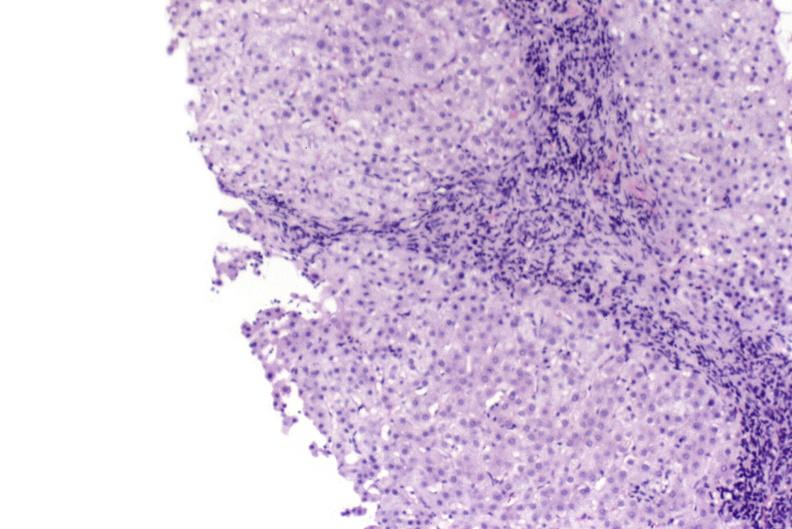does right leaf of diaphragm show primary biliary cirrhosis?
Answer the question using a single word or phrase. No 